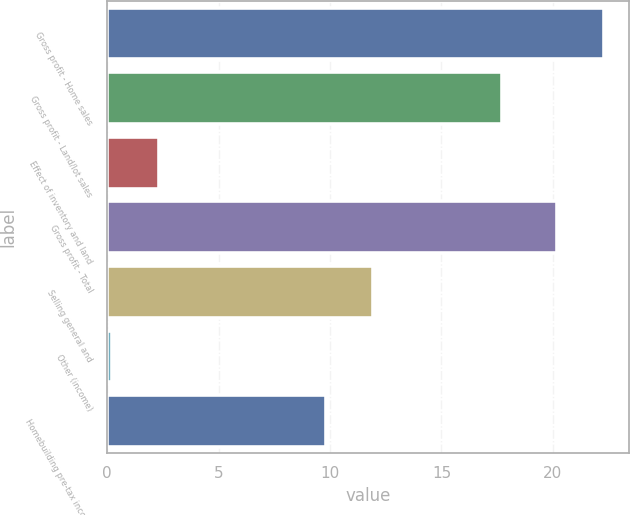Convert chart to OTSL. <chart><loc_0><loc_0><loc_500><loc_500><bar_chart><fcel>Gross profit - Home sales<fcel>Gross profit - Land/lot sales<fcel>Effect of inventory and land<fcel>Gross profit - Total<fcel>Selling general and<fcel>Other (income)<fcel>Homebuilding pre-tax income<nl><fcel>22.31<fcel>17.7<fcel>2.31<fcel>20.2<fcel>11.91<fcel>0.2<fcel>9.8<nl></chart> 